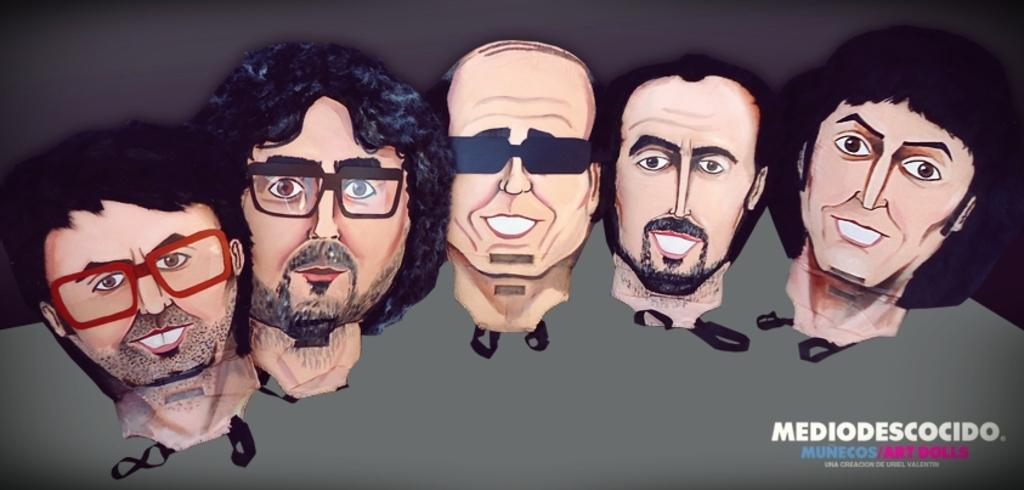What is depicted in the image? There is a cartoon face of persons in the image. Where can some text be found in the image? The text is located on the bottom right side of the image. What type of attack is being launched from the volcano in the image? There is no volcano present in the image, so it is not possible to answer that question. 